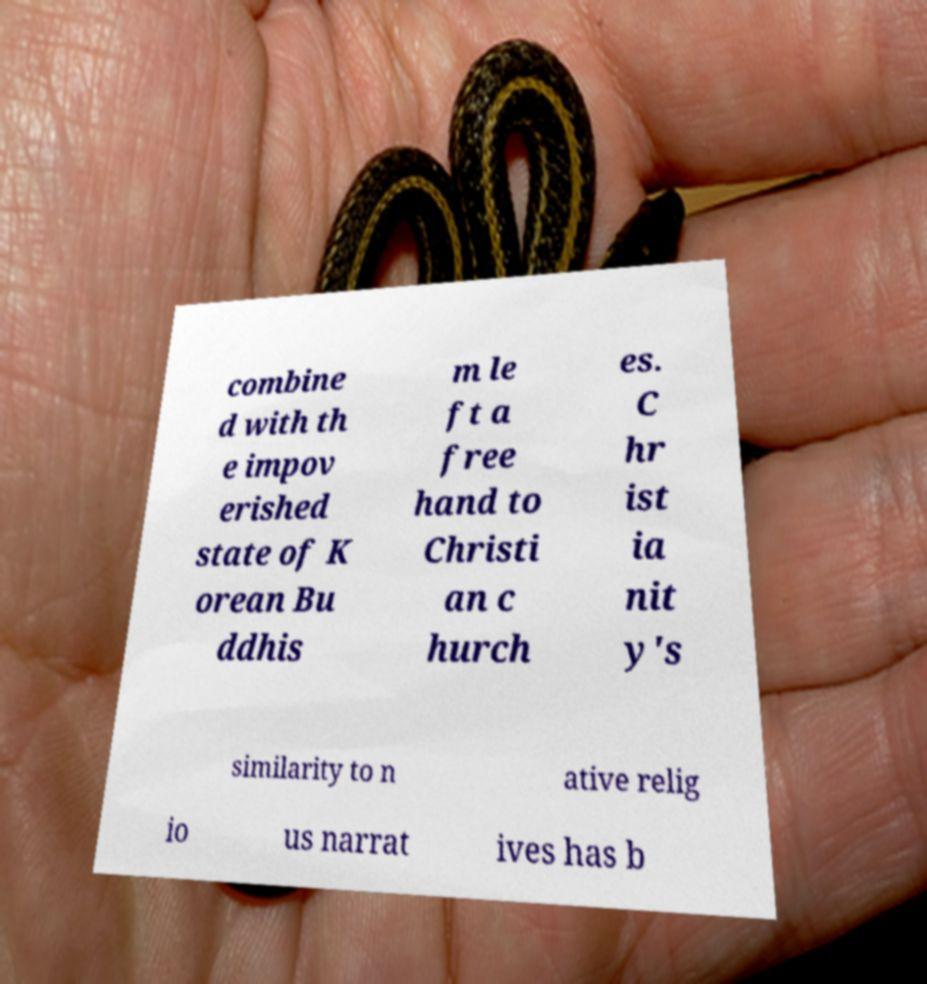For documentation purposes, I need the text within this image transcribed. Could you provide that? combine d with th e impov erished state of K orean Bu ddhis m le ft a free hand to Christi an c hurch es. C hr ist ia nit y's similarity to n ative relig io us narrat ives has b 